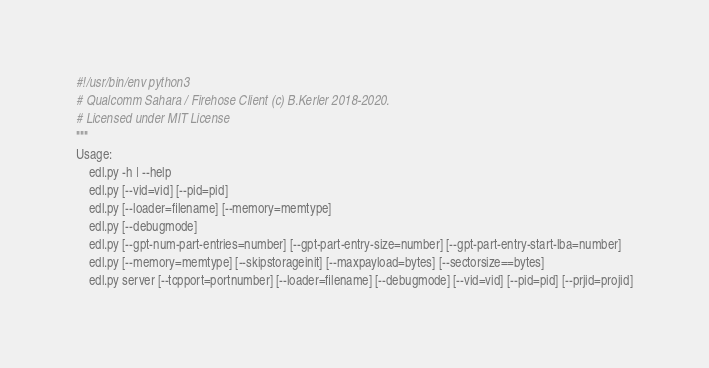Convert code to text. <code><loc_0><loc_0><loc_500><loc_500><_Python_>#!/usr/bin/env python3
# Qualcomm Sahara / Firehose Client (c) B.Kerler 2018-2020.
# Licensed under MIT License
"""
Usage:
    edl.py -h | --help
    edl.py [--vid=vid] [--pid=pid]
    edl.py [--loader=filename] [--memory=memtype]
    edl.py [--debugmode]
    edl.py [--gpt-num-part-entries=number] [--gpt-part-entry-size=number] [--gpt-part-entry-start-lba=number]
    edl.py [--memory=memtype] [--skipstorageinit] [--maxpayload=bytes] [--sectorsize==bytes]
    edl.py server [--tcpport=portnumber] [--loader=filename] [--debugmode] [--vid=vid] [--pid=pid] [--prjid=projid]</code> 